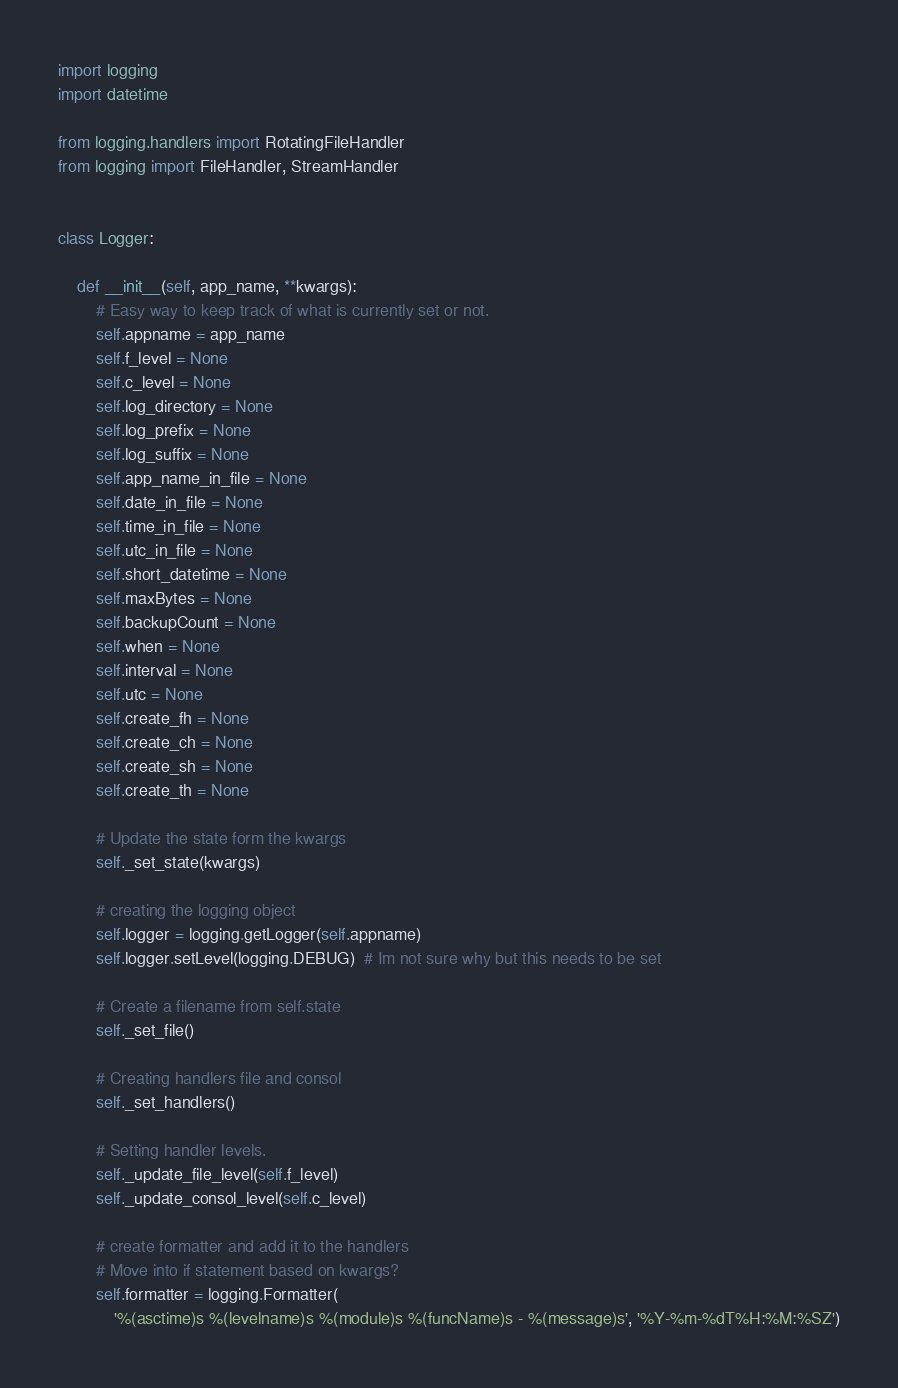<code> <loc_0><loc_0><loc_500><loc_500><_Python_>import logging
import datetime

from logging.handlers import RotatingFileHandler
from logging import FileHandler, StreamHandler


class Logger:

    def __init__(self, app_name, **kwargs):
        # Easy way to keep track of what is currently set or not.
        self.appname = app_name
        self.f_level = None
        self.c_level = None
        self.log_directory = None
        self.log_prefix = None
        self.log_suffix = None
        self.app_name_in_file = None
        self.date_in_file = None
        self.time_in_file = None
        self.utc_in_file = None
        self.short_datetime = None
        self.maxBytes = None
        self.backupCount = None
        self.when = None
        self.interval = None
        self.utc = None
        self.create_fh = None
        self.create_ch = None
        self.create_sh = None
        self.create_th = None

        # Update the state form the kwargs
        self._set_state(kwargs)

        # creating the logging object
        self.logger = logging.getLogger(self.appname)
        self.logger.setLevel(logging.DEBUG)  # Im not sure why but this needs to be set

        # Create a filename from self.state
        self._set_file()

        # Creating handlers file and consol
        self._set_handlers()

        # Setting handler levels.
        self._update_file_level(self.f_level)
        self._update_consol_level(self.c_level)

        # create formatter and add it to the handlers
        # Move into if statement based on kwargs?
        self.formatter = logging.Formatter(
            '%(asctime)s %(levelname)s %(module)s %(funcName)s - %(message)s', '%Y-%m-%dT%H:%M:%SZ')
</code> 